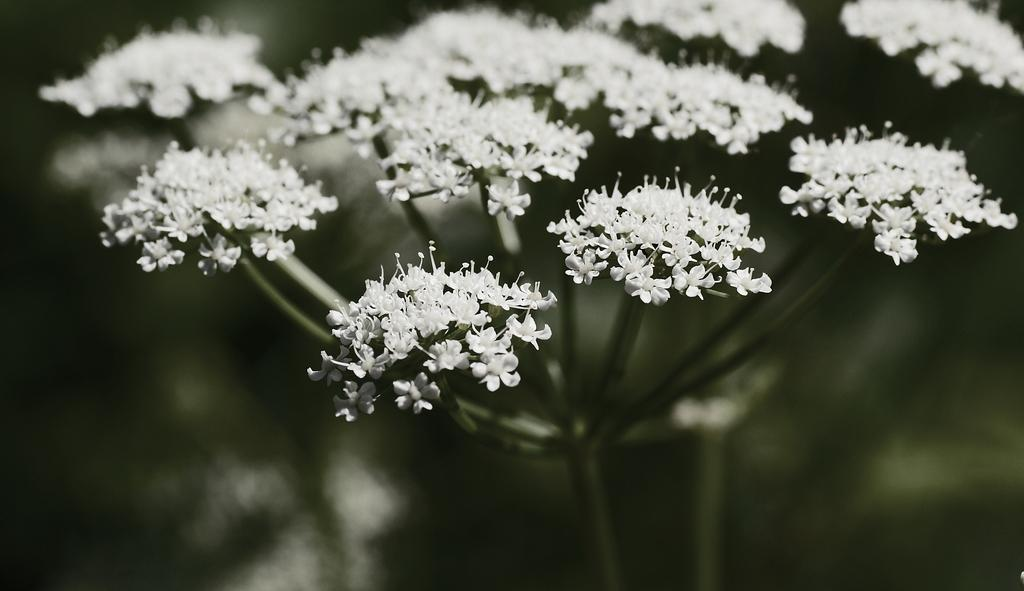What type of flowers can be seen on the plant in the image? There are white color flowers on a plant in the image. What is the color scheme of the image? The image is black and white. How would you describe the background of the image? The background of the image is blurred. How many slaves are visible in the image? There are no slaves present in the image. What type of form is used to create the flowers in the image? The image is black and white, and there is no indication of the form used to create the flowers. 